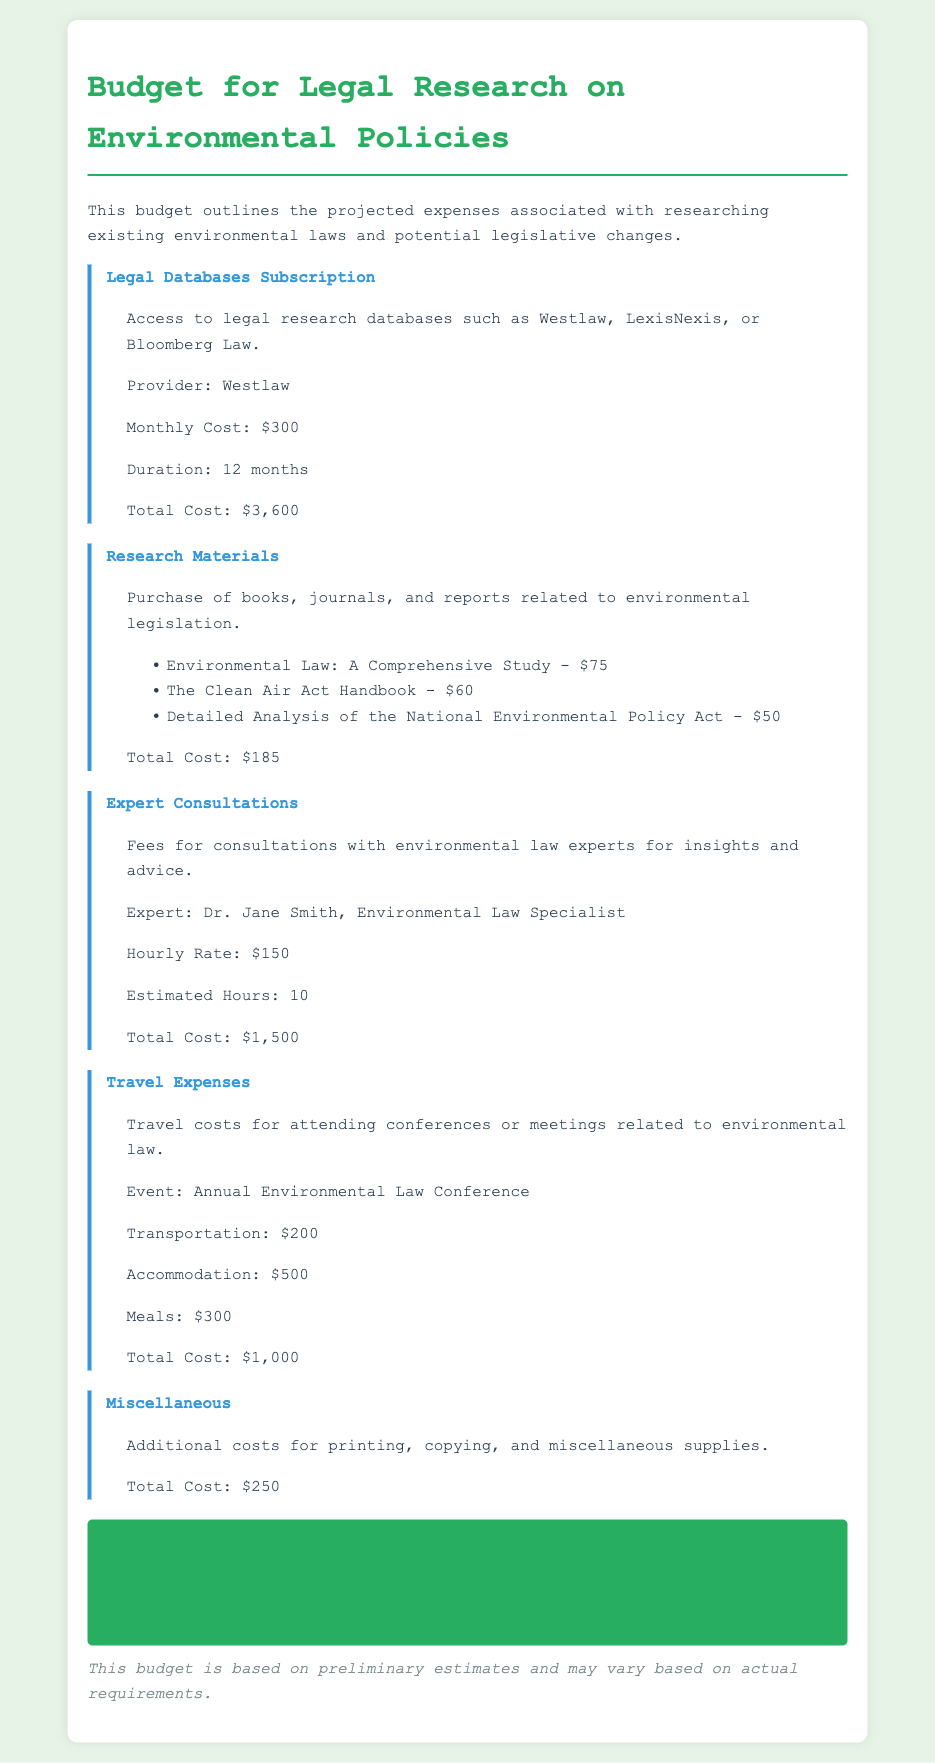What is the total cost for Legal Databases Subscription? The total cost for the Legal Databases Subscription is outlined in the document as $3,600.
Answer: $3,600 Who is the expert consulted for insights? The document specifies Dr. Jane Smith as the environmental law specialist consulted for insights.
Answer: Dr. Jane Smith What is the estimated cost for Research Materials? The expenses for Research Materials are detailed, and the total cost is $185.
Answer: $185 How much is allocated for Travel Expenses? The document lists the total allocated for Travel Expenses as $1,000.
Answer: $1,000 What is the total budget for all research expenses? The total budget for all research expenses is calculated and presented as $6,535.
Answer: $6,535 What type of event incurs Travel Expenses? The document mentions the Annual Environmental Law Conference as the event related to Travel Expenses.
Answer: Annual Environmental Law Conference What is the monthly cost for the Legal Databases Subscription? The document indicates that the monthly cost for the Legal Databases Subscription is $300.
Answer: $300 What is included in Miscellaneous expenses? The Miscellaneous expenses cover printing, copying, and miscellaneous supplies as noted in the document.
Answer: Printing, copying, and miscellaneous supplies 